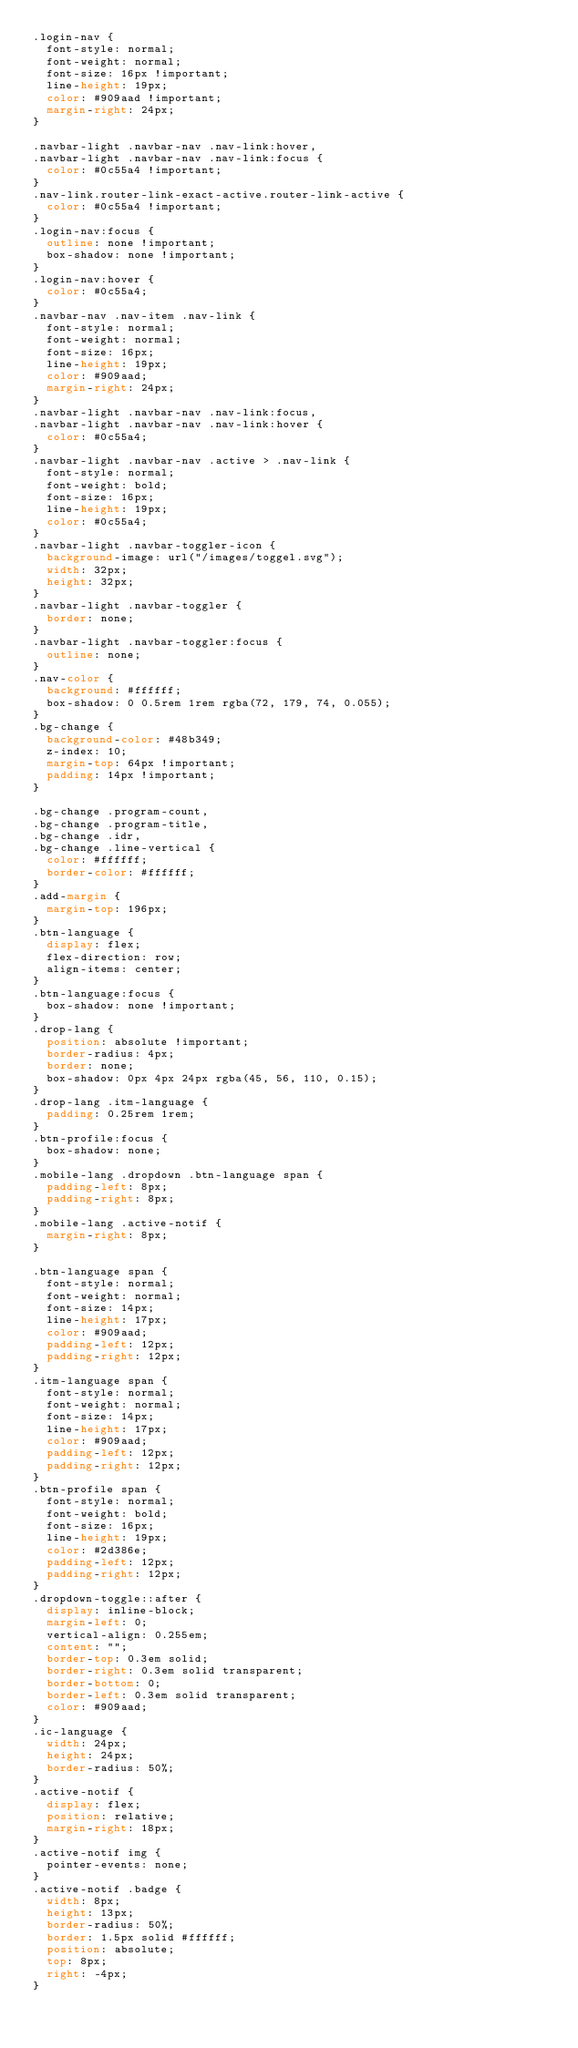<code> <loc_0><loc_0><loc_500><loc_500><_CSS_>.login-nav {
  font-style: normal;
  font-weight: normal;
  font-size: 16px !important;
  line-height: 19px;
  color: #909aad !important;
  margin-right: 24px;
}

.navbar-light .navbar-nav .nav-link:hover,
.navbar-light .navbar-nav .nav-link:focus {
  color: #0c55a4 !important;
}
.nav-link.router-link-exact-active.router-link-active {
  color: #0c55a4 !important;
}
.login-nav:focus {
  outline: none !important;
  box-shadow: none !important;
}
.login-nav:hover {
  color: #0c55a4;
}
.navbar-nav .nav-item .nav-link {
  font-style: normal;
  font-weight: normal;
  font-size: 16px;
  line-height: 19px;
  color: #909aad;
  margin-right: 24px;
}
.navbar-light .navbar-nav .nav-link:focus,
.navbar-light .navbar-nav .nav-link:hover {
  color: #0c55a4;
}
.navbar-light .navbar-nav .active > .nav-link {
  font-style: normal;
  font-weight: bold;
  font-size: 16px;
  line-height: 19px;
  color: #0c55a4;
}
.navbar-light .navbar-toggler-icon {
  background-image: url("/images/toggel.svg");
  width: 32px;
  height: 32px;
}
.navbar-light .navbar-toggler {
  border: none;
}
.navbar-light .navbar-toggler:focus {
  outline: none;
}
.nav-color {
  background: #ffffff;
  box-shadow: 0 0.5rem 1rem rgba(72, 179, 74, 0.055);
}
.bg-change {
  background-color: #48b349;
  z-index: 10;
  margin-top: 64px !important;
  padding: 14px !important;
}

.bg-change .program-count,
.bg-change .program-title,
.bg-change .idr,
.bg-change .line-vertical {
  color: #ffffff;
  border-color: #ffffff;
}
.add-margin {
  margin-top: 196px;
}
.btn-language {
  display: flex;
  flex-direction: row;
  align-items: center;
}
.btn-language:focus {
  box-shadow: none !important;
}
.drop-lang {
  position: absolute !important;
  border-radius: 4px;
  border: none;
  box-shadow: 0px 4px 24px rgba(45, 56, 110, 0.15);
}
.drop-lang .itm-language {
  padding: 0.25rem 1rem;
}
.btn-profile:focus {
  box-shadow: none;
}
.mobile-lang .dropdown .btn-language span {
  padding-left: 8px;
  padding-right: 8px;
}
.mobile-lang .active-notif {
  margin-right: 8px;
}

.btn-language span {
  font-style: normal;
  font-weight: normal;
  font-size: 14px;
  line-height: 17px;
  color: #909aad;
  padding-left: 12px;
  padding-right: 12px;
}
.itm-language span {
  font-style: normal;
  font-weight: normal;
  font-size: 14px;
  line-height: 17px;
  color: #909aad;
  padding-left: 12px;
  padding-right: 12px;
}
.btn-profile span {
  font-style: normal;
  font-weight: bold;
  font-size: 16px;
  line-height: 19px;
  color: #2d386e;
  padding-left: 12px;
  padding-right: 12px;
}
.dropdown-toggle::after {
  display: inline-block;
  margin-left: 0;
  vertical-align: 0.255em;
  content: "";
  border-top: 0.3em solid;
  border-right: 0.3em solid transparent;
  border-bottom: 0;
  border-left: 0.3em solid transparent;
  color: #909aad;
}
.ic-language {
  width: 24px;
  height: 24px;
  border-radius: 50%;
}
.active-notif {
  display: flex;
  position: relative;
  margin-right: 18px;
}
.active-notif img {
  pointer-events: none;
}
.active-notif .badge {
  width: 8px;
  height: 13px;
  border-radius: 50%;
  border: 1.5px solid #ffffff;
  position: absolute;
  top: 8px;
  right: -4px;
}
</code> 